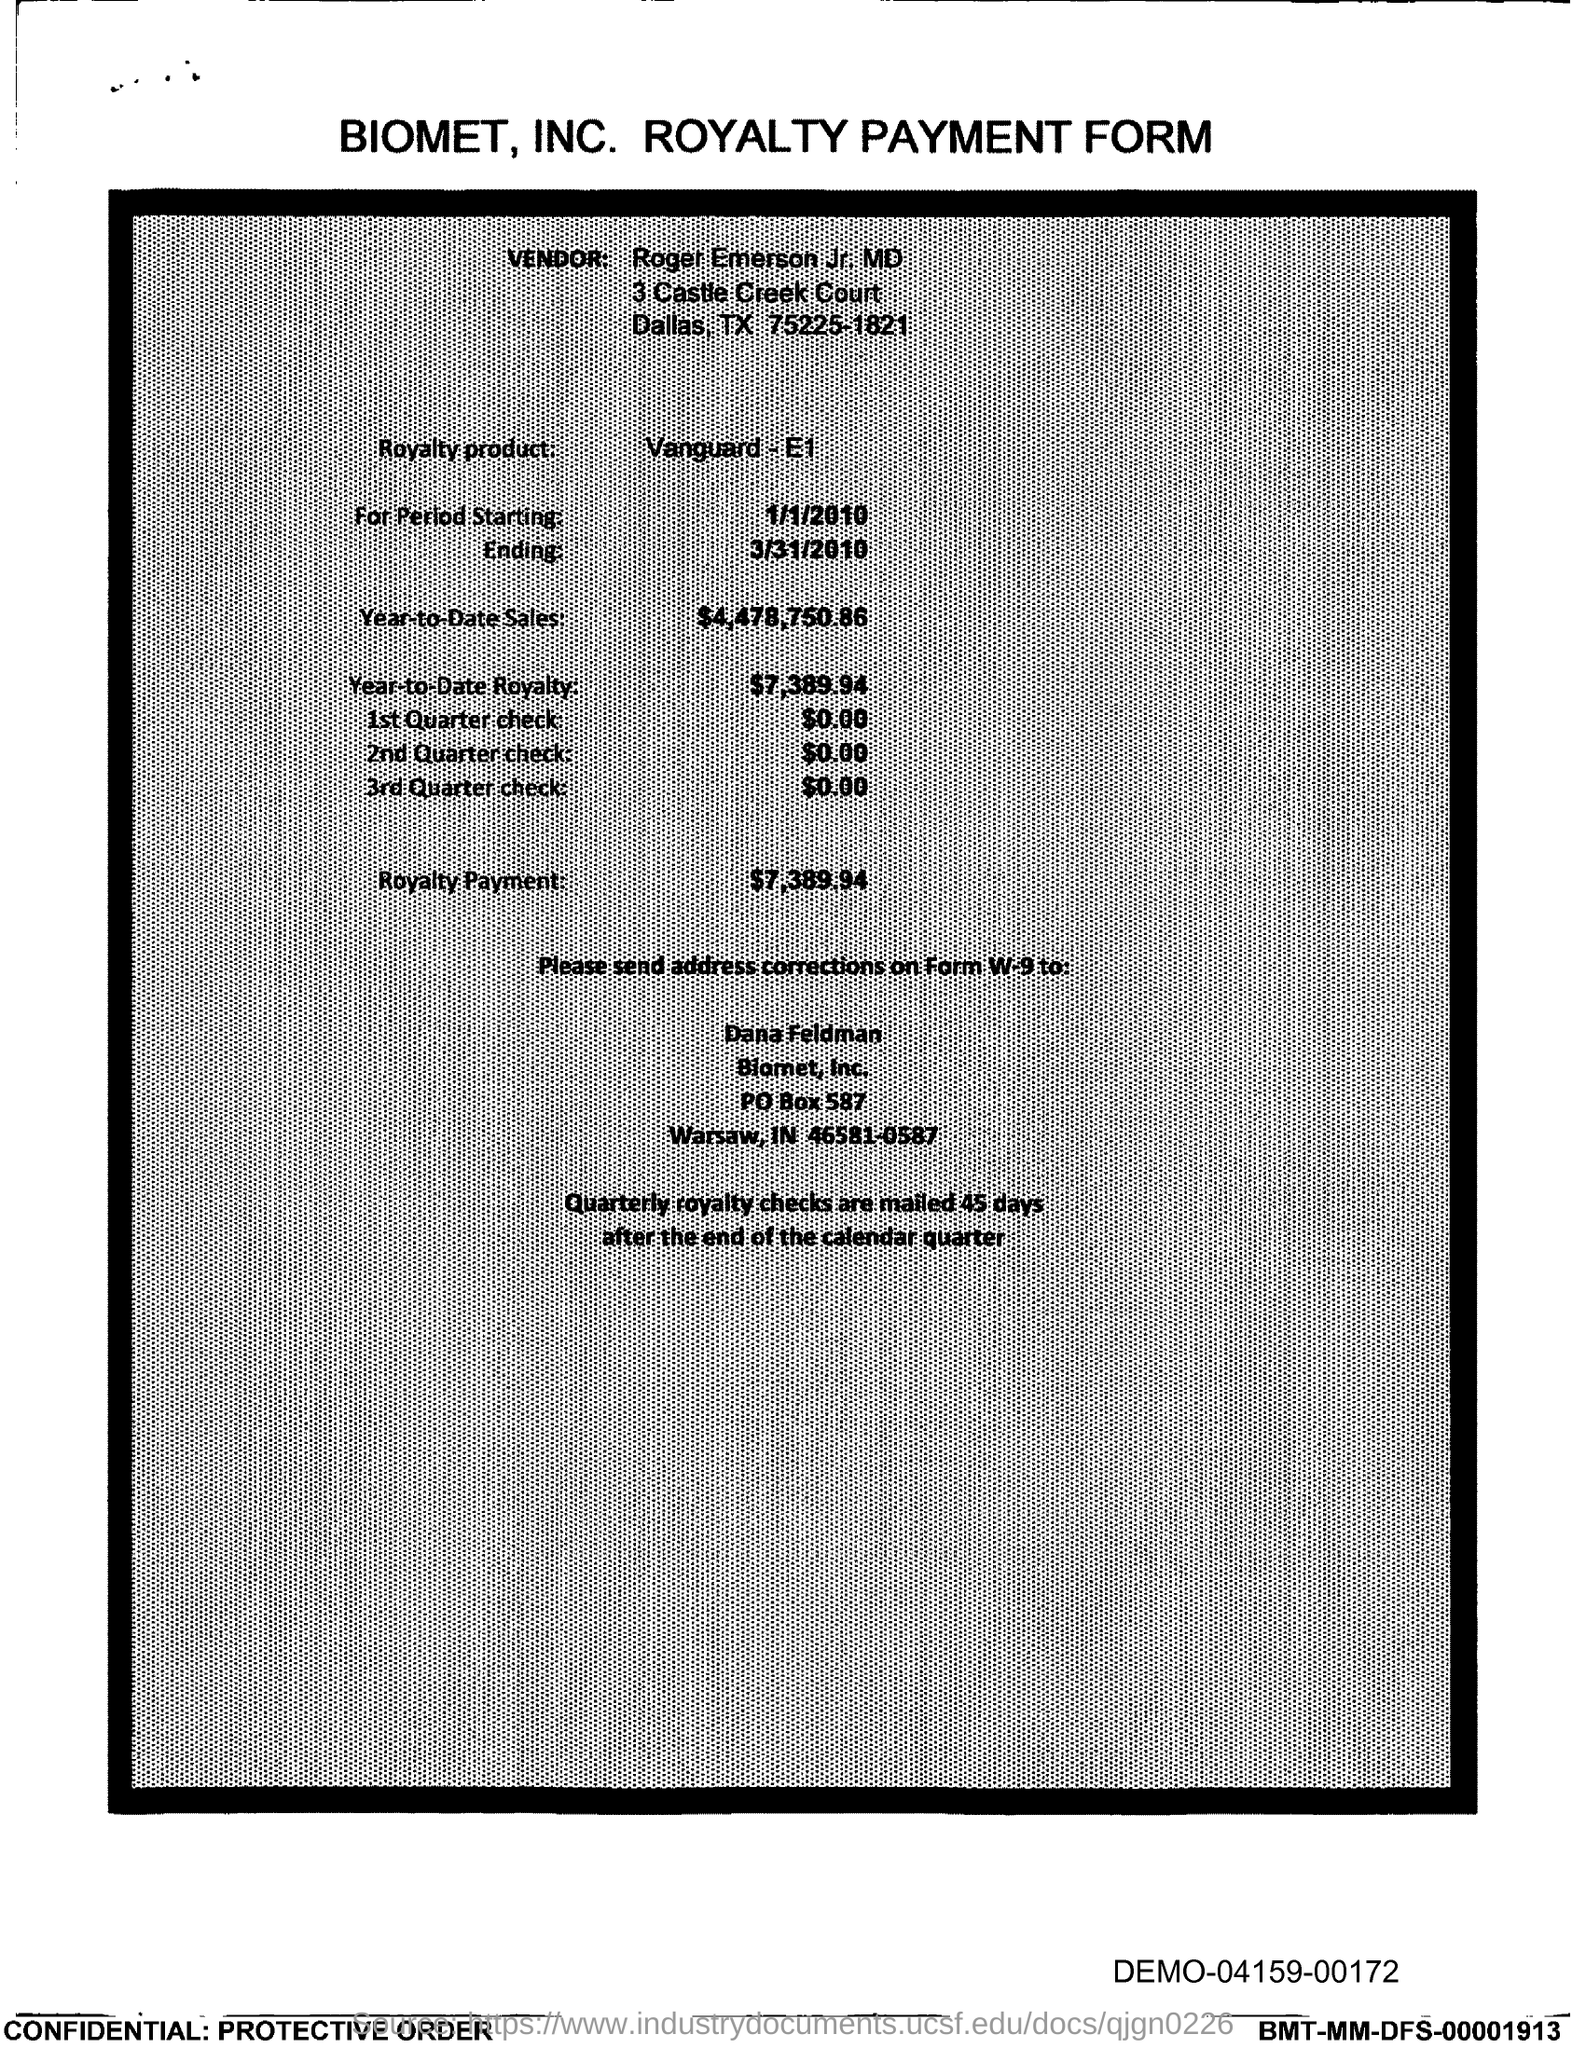What is the Royalty product mentioned?
Keep it short and to the point. VANGUARD- E1. What is the amount of Year-to-Date Sales?
Your answer should be compact. $4,478,750.86. What is Royalty Payment specified?
Offer a terse response. $7,389.94. To whom should address corrections on Form W-9 be sent?
Keep it short and to the point. DANA FELDMAN. 